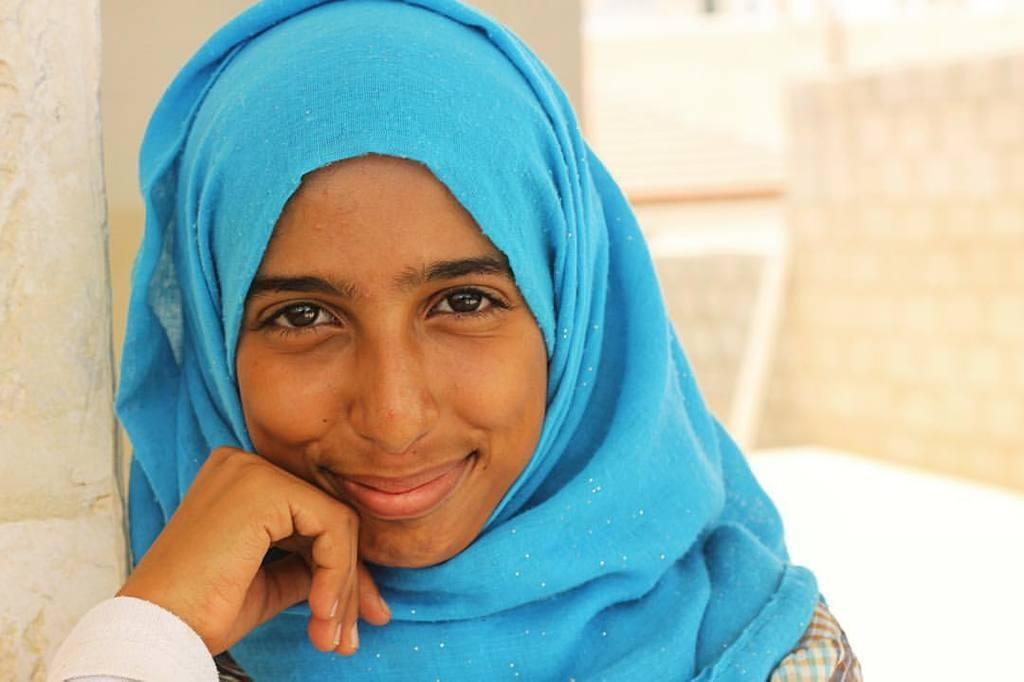Who is the main subject in the image? There is a girl in the image. Where is the girl located in the image? The girl is on the left side of the image. What type of cakes can be seen on the playground in the image? There is no playground or cakes present in the image; it only features a girl on the left side. 